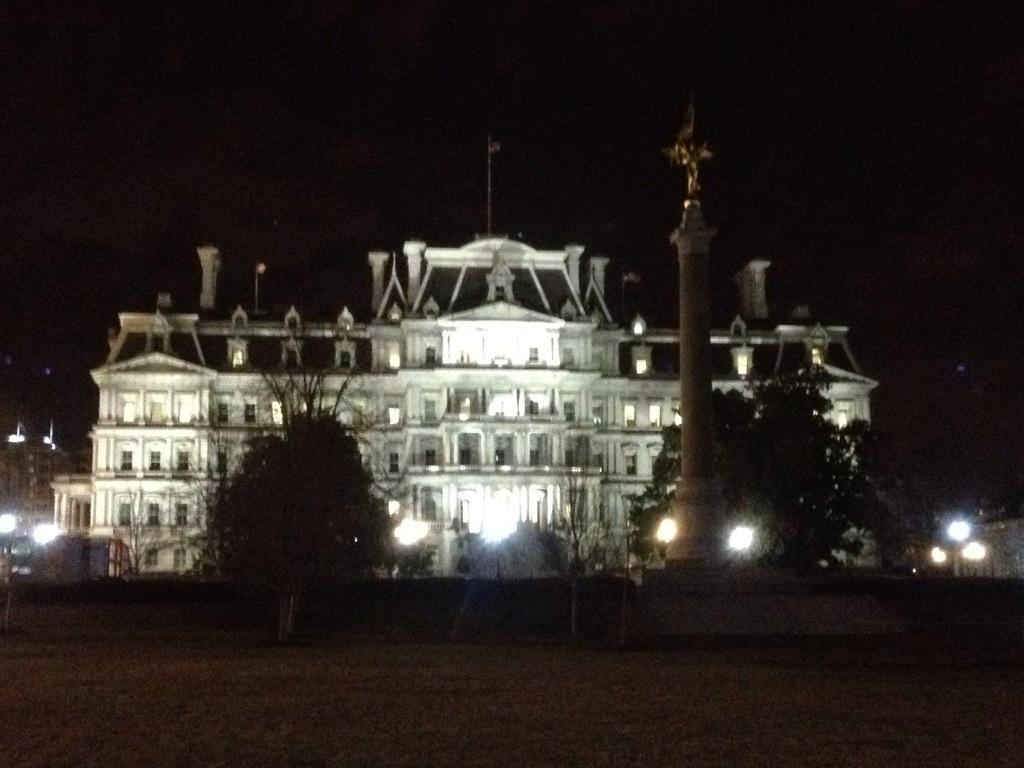What type of natural elements can be seen in the image? There are trees in the image. What object is present in the image that might be used for support or attachment? There is a pole in the image. What can be seen attached to the pole in the image? There are lights in the image. What type of structure is visible in the background of the image? There is a building in the background of the image. What are some features of the building's construction? The building has walls, windows, and pillars. What type of medical advice is the doctor providing in the image? There is no doctor present in the image, so no medical advice can be provided. What type of wind can be seen blowing through the image? There is no wind present in the image; it is a still image. 